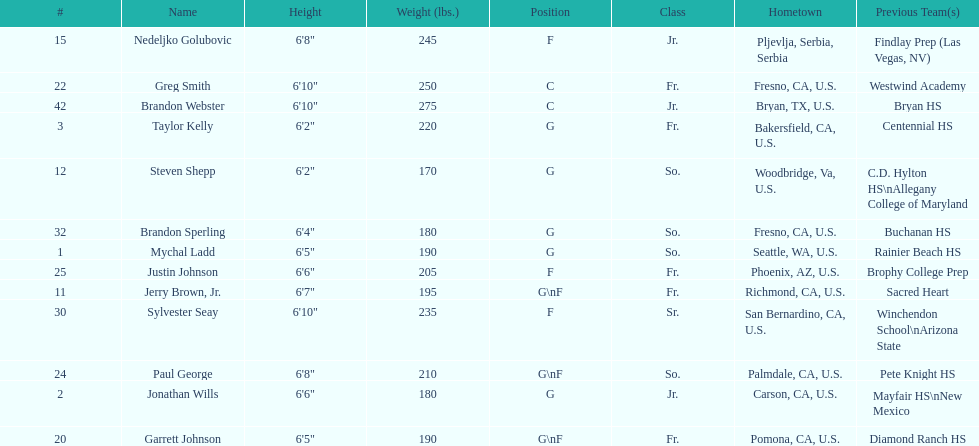How many players and both guard (g) and forward (f)? 3. 